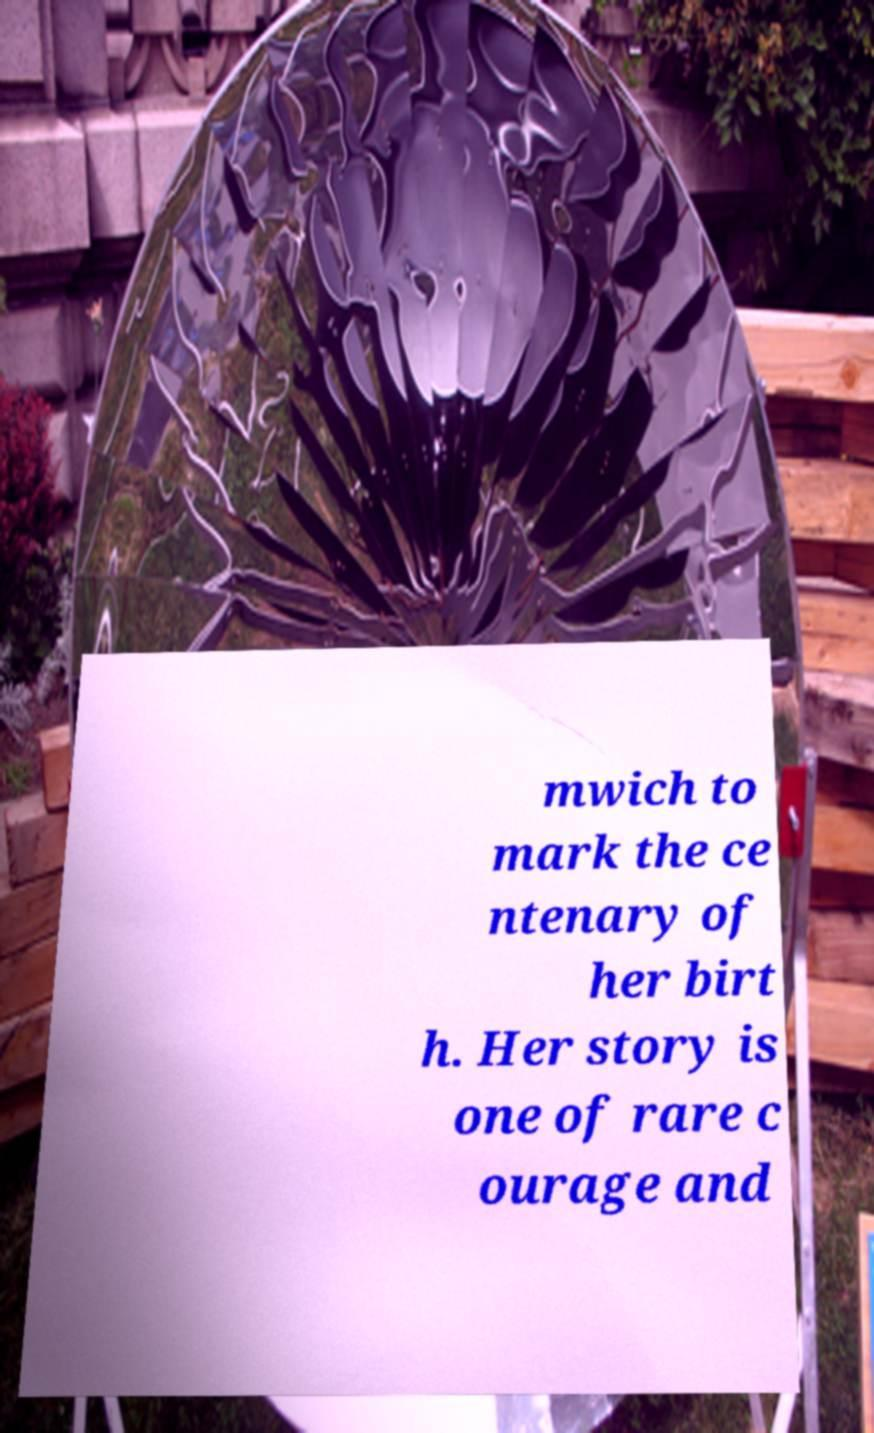Could you assist in decoding the text presented in this image and type it out clearly? mwich to mark the ce ntenary of her birt h. Her story is one of rare c ourage and 